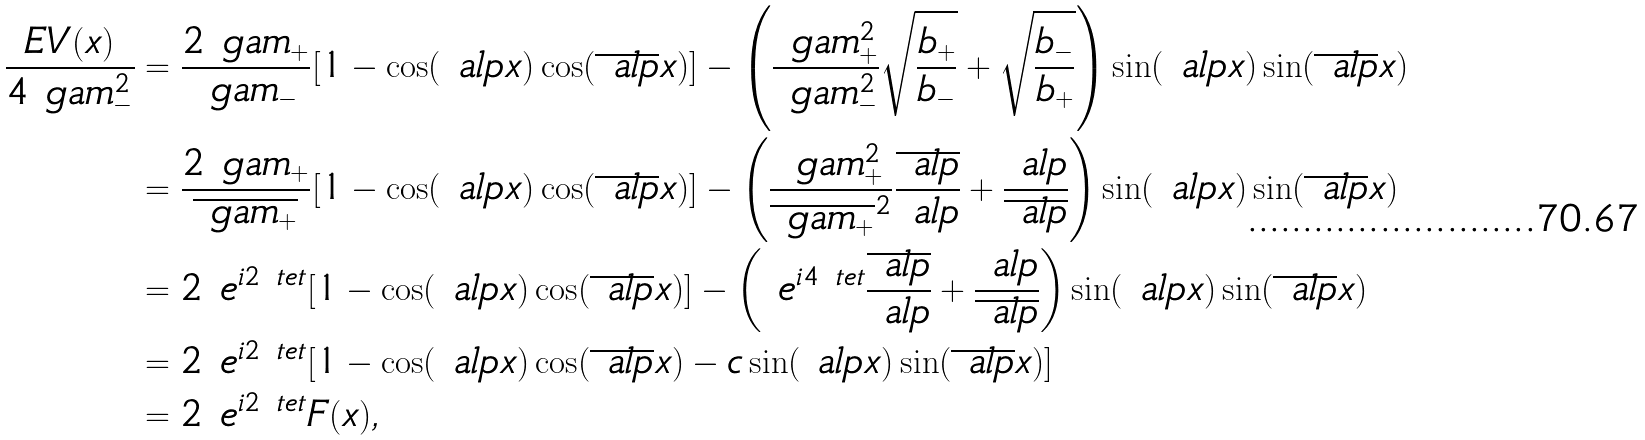Convert formula to latex. <formula><loc_0><loc_0><loc_500><loc_500>\frac { E V ( x ) } { 4 \ g a m _ { - } ^ { 2 } } & = \frac { 2 \ g a m _ { + } } { \ g a m _ { - } } [ 1 - \cos ( \ a l p x ) \cos ( \overline { \ a l p } x ) ] - \left ( \frac { \ g a m _ { + } ^ { 2 } } { \ g a m _ { - } ^ { 2 } } \sqrt { \frac { b _ { + } } { b _ { - } } } + \sqrt { \frac { b _ { - } } { b _ { + } } } \right ) \sin ( \ a l p x ) \sin ( \overline { \ a l p } x ) \\ & = \frac { 2 \ g a m _ { + } } { \overline { \ g a m _ { + } } } [ 1 - \cos ( \ a l p x ) \cos ( \overline { \ a l p } x ) ] - \left ( \frac { \ g a m _ { + } ^ { 2 } } { \overline { \ g a m _ { + } } ^ { 2 } } \frac { \overline { \ a l p } } { \ a l p } + \frac { \ a l p } { \overline { \ a l p } } \right ) \sin ( \ a l p x ) \sin ( \overline { \ a l p } x ) \\ & = 2 \ e ^ { i 2 \ t e t } [ 1 - \cos ( \ a l p x ) \cos ( \overline { \ a l p } x ) ] - \left ( \ e ^ { i 4 \ t e t } \frac { \overline { \ a l p } } { \ a l p } + \frac { \ a l p } { \overline { \ a l p } } \right ) \sin ( \ a l p x ) \sin ( \overline { \ a l p } x ) \\ & = 2 \ e ^ { i 2 \ t e t } [ 1 - \cos ( \ a l p x ) \cos ( \overline { \ a l p } x ) - c \sin ( \ a l p x ) \sin ( \overline { \ a l p } x ) ] \\ & = 2 \ e ^ { i 2 \ t e t } F ( x ) ,</formula> 